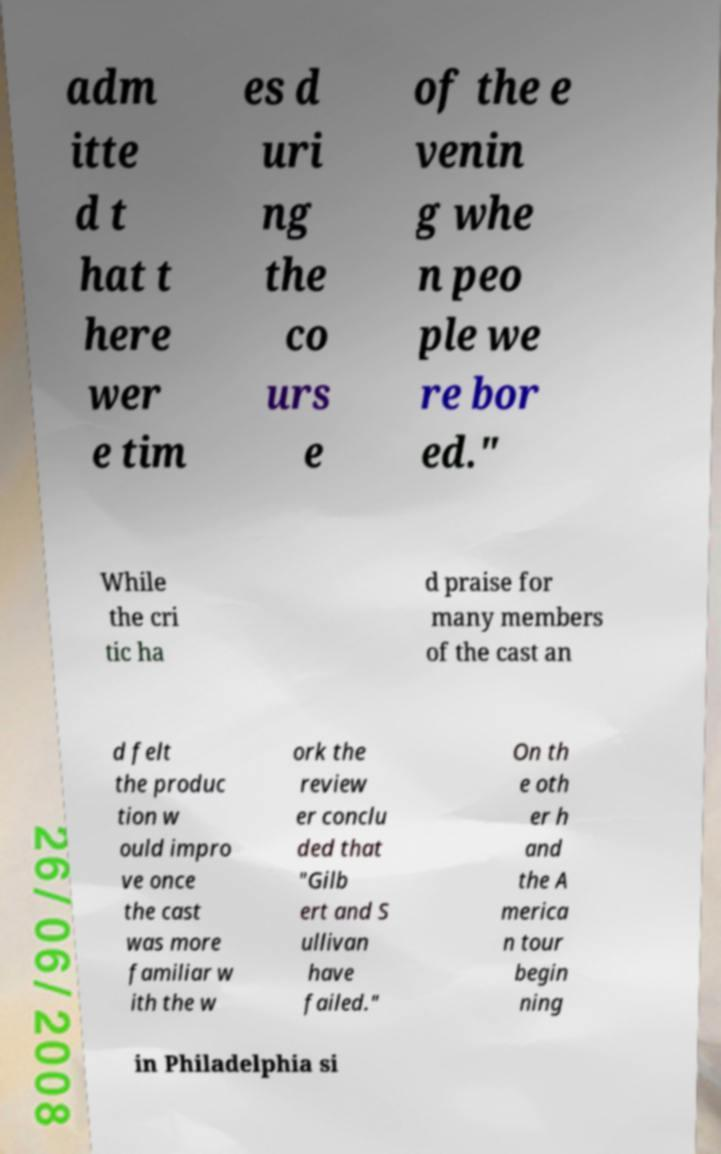Could you extract and type out the text from this image? adm itte d t hat t here wer e tim es d uri ng the co urs e of the e venin g whe n peo ple we re bor ed." While the cri tic ha d praise for many members of the cast an d felt the produc tion w ould impro ve once the cast was more familiar w ith the w ork the review er conclu ded that "Gilb ert and S ullivan have failed." On th e oth er h and the A merica n tour begin ning in Philadelphia si 